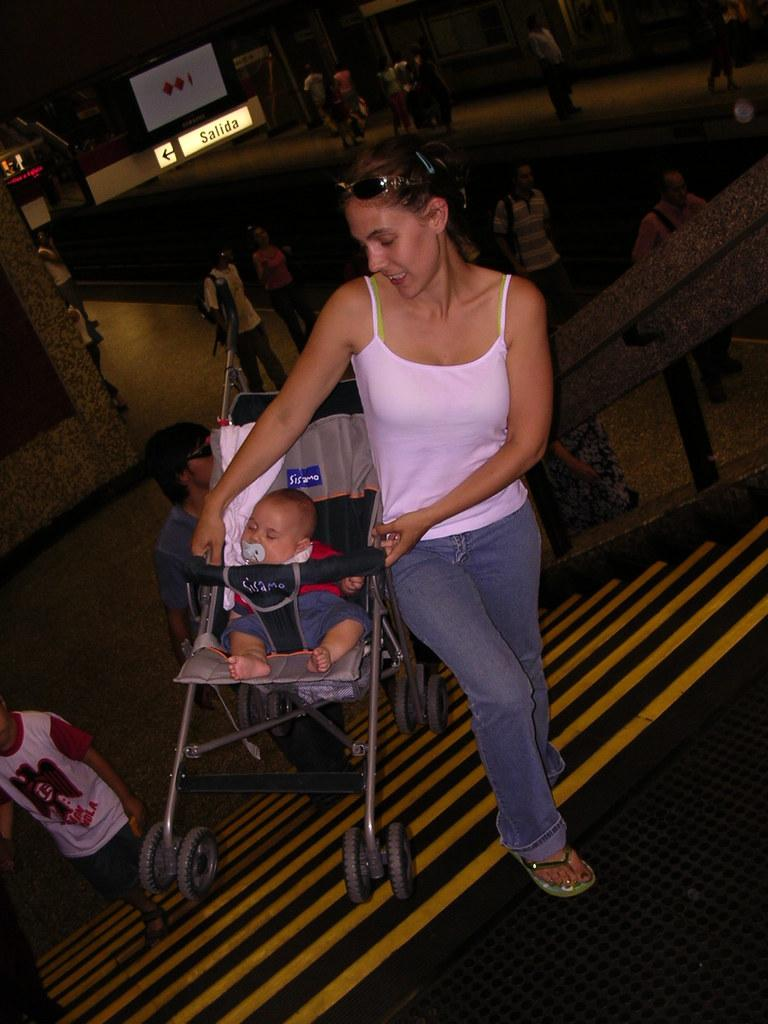<image>
Relay a brief, clear account of the picture shown. Salida is behind the woman and to the left. 